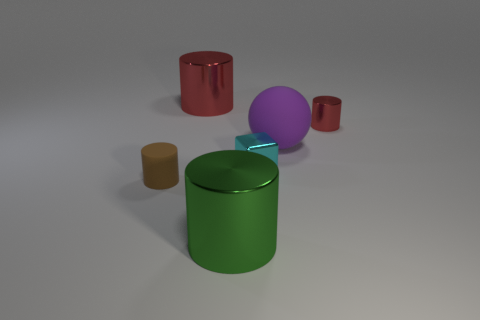Add 3 small cyan spheres. How many objects exist? 9 Subtract all cubes. How many objects are left? 5 Add 6 green metal things. How many green metal things are left? 7 Add 1 small purple metal spheres. How many small purple metal spheres exist? 1 Subtract 0 gray cylinders. How many objects are left? 6 Subtract all purple matte spheres. Subtract all small purple objects. How many objects are left? 5 